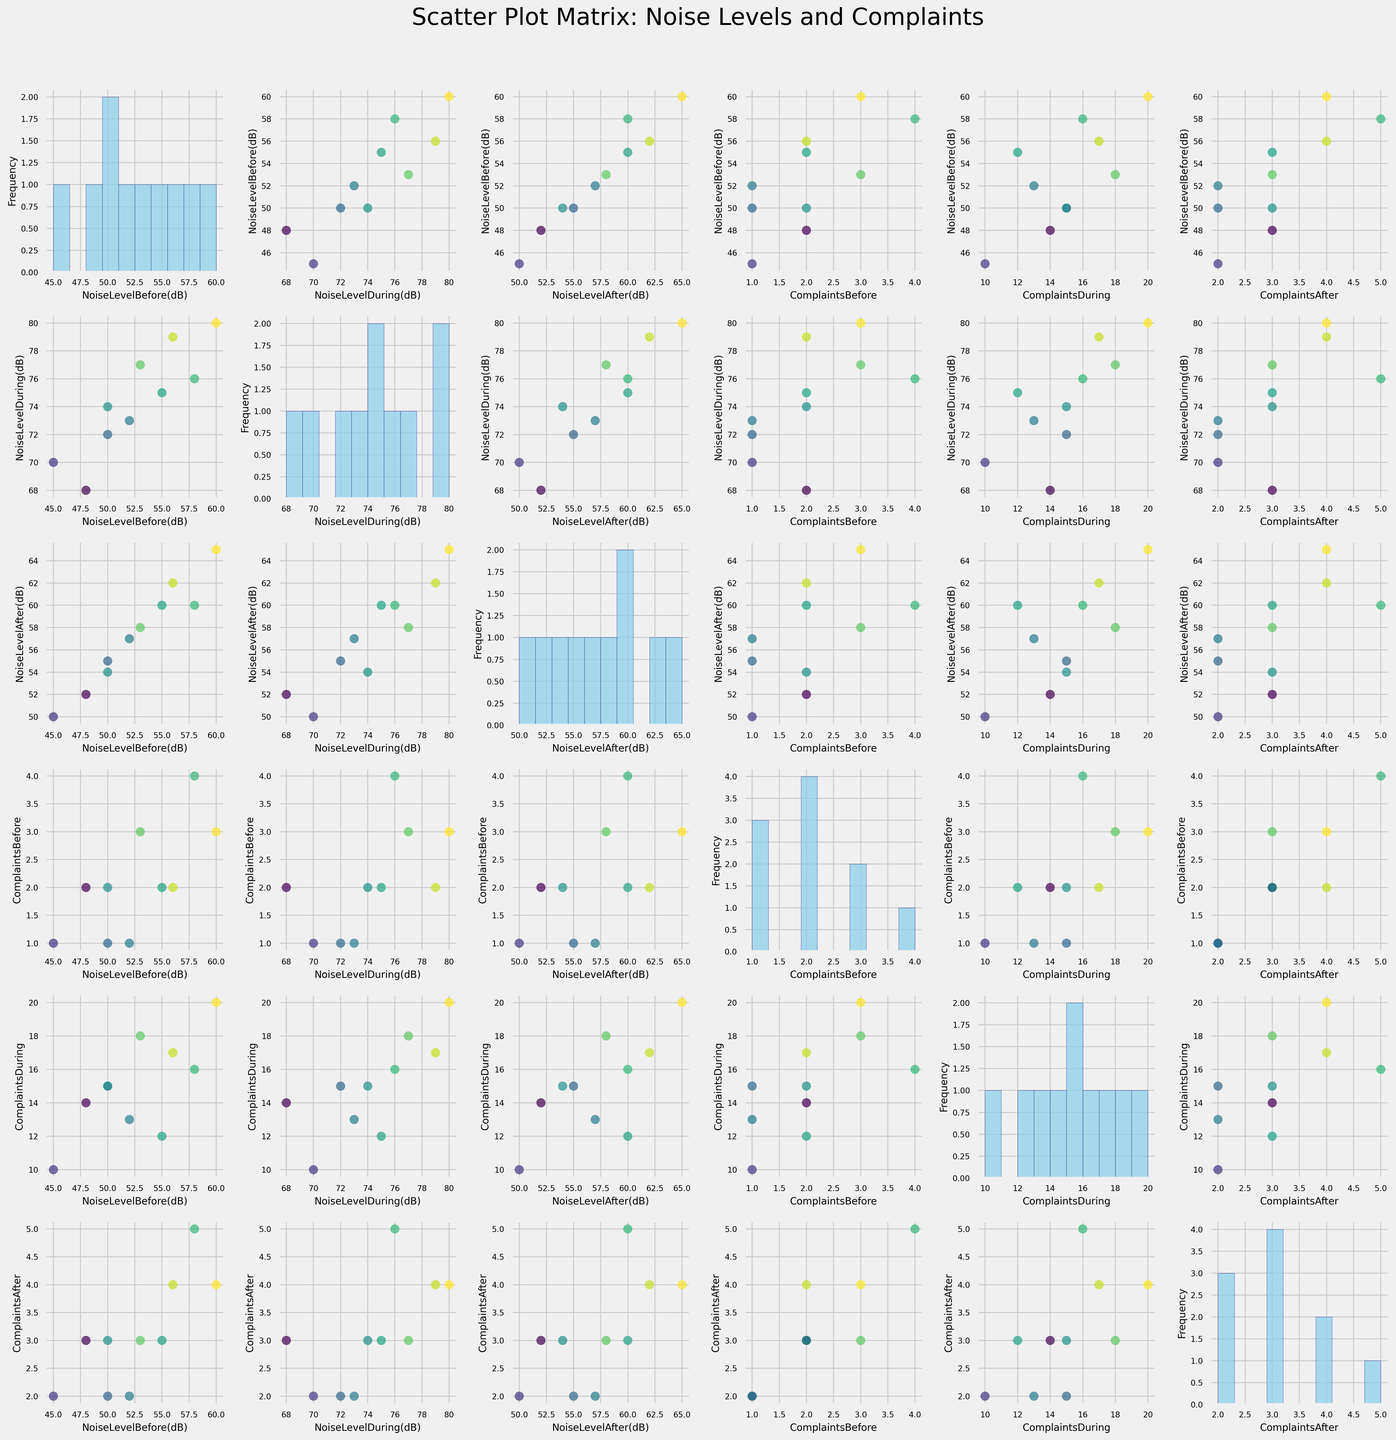How many buildings are included in this figure? There are multiple scatter plots in the figure, each representing data from the 10 listed buildings (Sunset Apartments, Maple Residence, Pinewood Tower, Harbor View Condos, Lakeside Villas, Riverbank Homes, Hilltop Estates, City Center Lofts, Ocean Breeze Flats, Greenfield Park Residences).
Answer: 10 What is the general trend in noise levels during construction compared to before construction? By looking at the scatter plots where 'NoiseLevelDuring(dB)' is on one axis and 'NoiseLevelBefore(dB)' on the other, it is evident that most points are above a 45-degree reference line, indicating higher noise levels during construction compared to before.
Answer: Noise levels during construction are generally higher than before construction Which scatter plot and histograms show the highest number of complaints compared to noise levels after construction? By examining the subplots where 'ComplaintsAfter' is either of the axes, specifically 'ComplaintsAfter' vs 'NoiseLevelAfter(dB)', and relevant histograms, we see that more complaints tend to correspond with noise levels after construction.
Answer: 'ComplaintsAfter' vs 'NoiseLevelAfter(dB)' scatter plot and relevant histograms Which building had the highest noise level during construction, and how does its noise level and complaints trend compare to before and after? Identifying the highest noise level point on the 'NoiseLevelDuring(dB)' histograms shows Pinewood Tower at 80 dB. To compare, we must check scatter plots involving Pinewood Tower in all three conditions. Generally, it had lower noise before (60 dB) and after (65 dB), with a high number of complaints during (20) decreasing afterward (4).
Answer: Pinewood Tower, higher during, lower before and after, complaints reduce after construction Does the increase in noise levels during construction correlate with the number of complaints made during the same period? Checking scatter plots where 'NoiseLevelDuring(dB)' and 'ComplaintsDuring' axis intersect reveals a positive correlation. Higher noise levels during construction generally match more complaints.
Answer: Increased noise levels during construction correlate with an increase in complaints Is there a building where complaints after construction are as high as during construction? By comparing scatter plots and histograms involving 'ComplaintsDuring' and 'ComplaintsAfter', no building matches the high complaints during construction (20 max) with post-construction complaints (5 max being City Center Lofts).
Answer: No, complaints post-construction are lower What is the average noise level before construction? Adding the 'NoiseLevelBefore(dB)' values (55, 50, 60, 45, 48, 53, 56, 58, 52, 50) results in 527. Dividing by the number of buildings (10) gives the average.
Answer: 52.7 